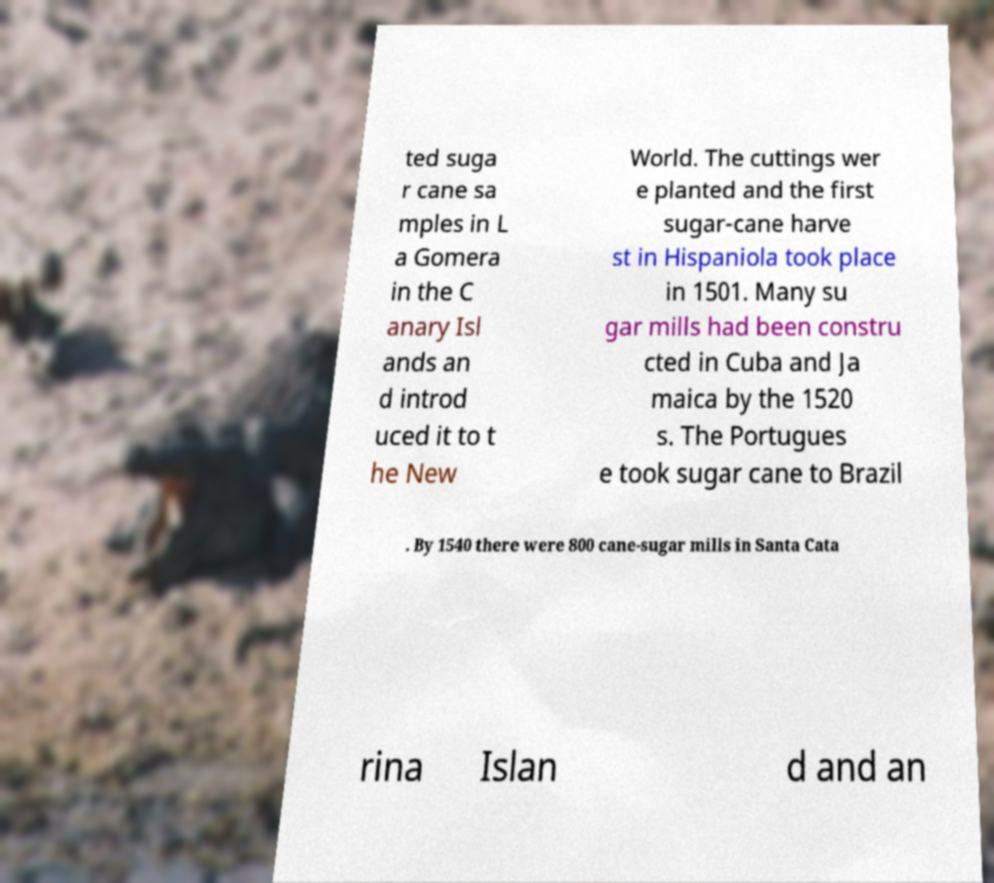For documentation purposes, I need the text within this image transcribed. Could you provide that? ted suga r cane sa mples in L a Gomera in the C anary Isl ands an d introd uced it to t he New World. The cuttings wer e planted and the first sugar-cane harve st in Hispaniola took place in 1501. Many su gar mills had been constru cted in Cuba and Ja maica by the 1520 s. The Portugues e took sugar cane to Brazil . By 1540 there were 800 cane-sugar mills in Santa Cata rina Islan d and an 